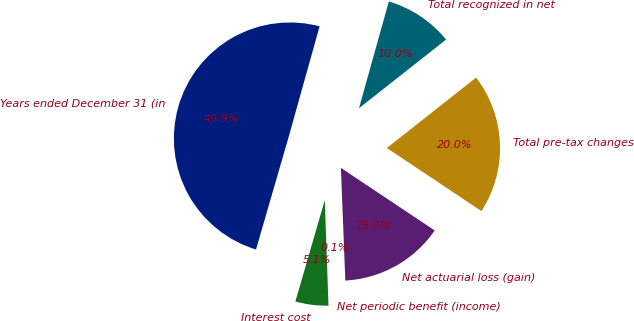Convert chart. <chart><loc_0><loc_0><loc_500><loc_500><pie_chart><fcel>Years ended December 31 (in<fcel>Interest cost<fcel>Net periodic benefit (income)<fcel>Net actuarial loss (gain)<fcel>Total pre-tax changes<fcel>Total recognized in net<nl><fcel>49.85%<fcel>5.05%<fcel>0.07%<fcel>15.01%<fcel>19.99%<fcel>10.03%<nl></chart> 